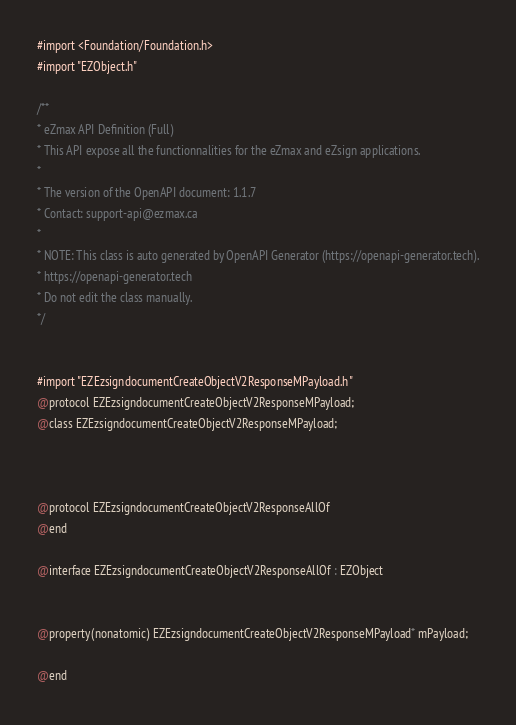<code> <loc_0><loc_0><loc_500><loc_500><_C_>#import <Foundation/Foundation.h>
#import "EZObject.h"

/**
* eZmax API Definition (Full)
* This API expose all the functionnalities for the eZmax and eZsign applications.
*
* The version of the OpenAPI document: 1.1.7
* Contact: support-api@ezmax.ca
*
* NOTE: This class is auto generated by OpenAPI Generator (https://openapi-generator.tech).
* https://openapi-generator.tech
* Do not edit the class manually.
*/


#import "EZEzsigndocumentCreateObjectV2ResponseMPayload.h"
@protocol EZEzsigndocumentCreateObjectV2ResponseMPayload;
@class EZEzsigndocumentCreateObjectV2ResponseMPayload;



@protocol EZEzsigndocumentCreateObjectV2ResponseAllOf
@end

@interface EZEzsigndocumentCreateObjectV2ResponseAllOf : EZObject


@property(nonatomic) EZEzsigndocumentCreateObjectV2ResponseMPayload* mPayload;

@end
</code> 